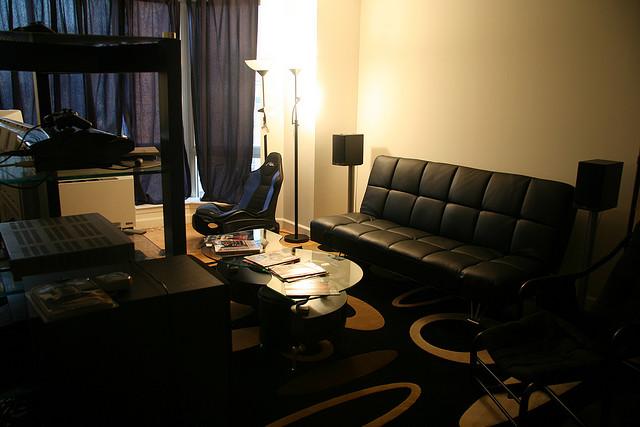What is on the table?
Be succinct. Magazines. What room is this?
Write a very short answer. Living room. Are all the lights in the photo on?
Short answer required. Yes. 